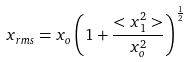Convert formula to latex. <formula><loc_0><loc_0><loc_500><loc_500>x _ { r m s } = x _ { o } \left ( 1 + \frac { < x _ { 1 } ^ { 2 } > } { x _ { o } ^ { 2 } } \right ) ^ { \frac { 1 } { 2 } }</formula> 